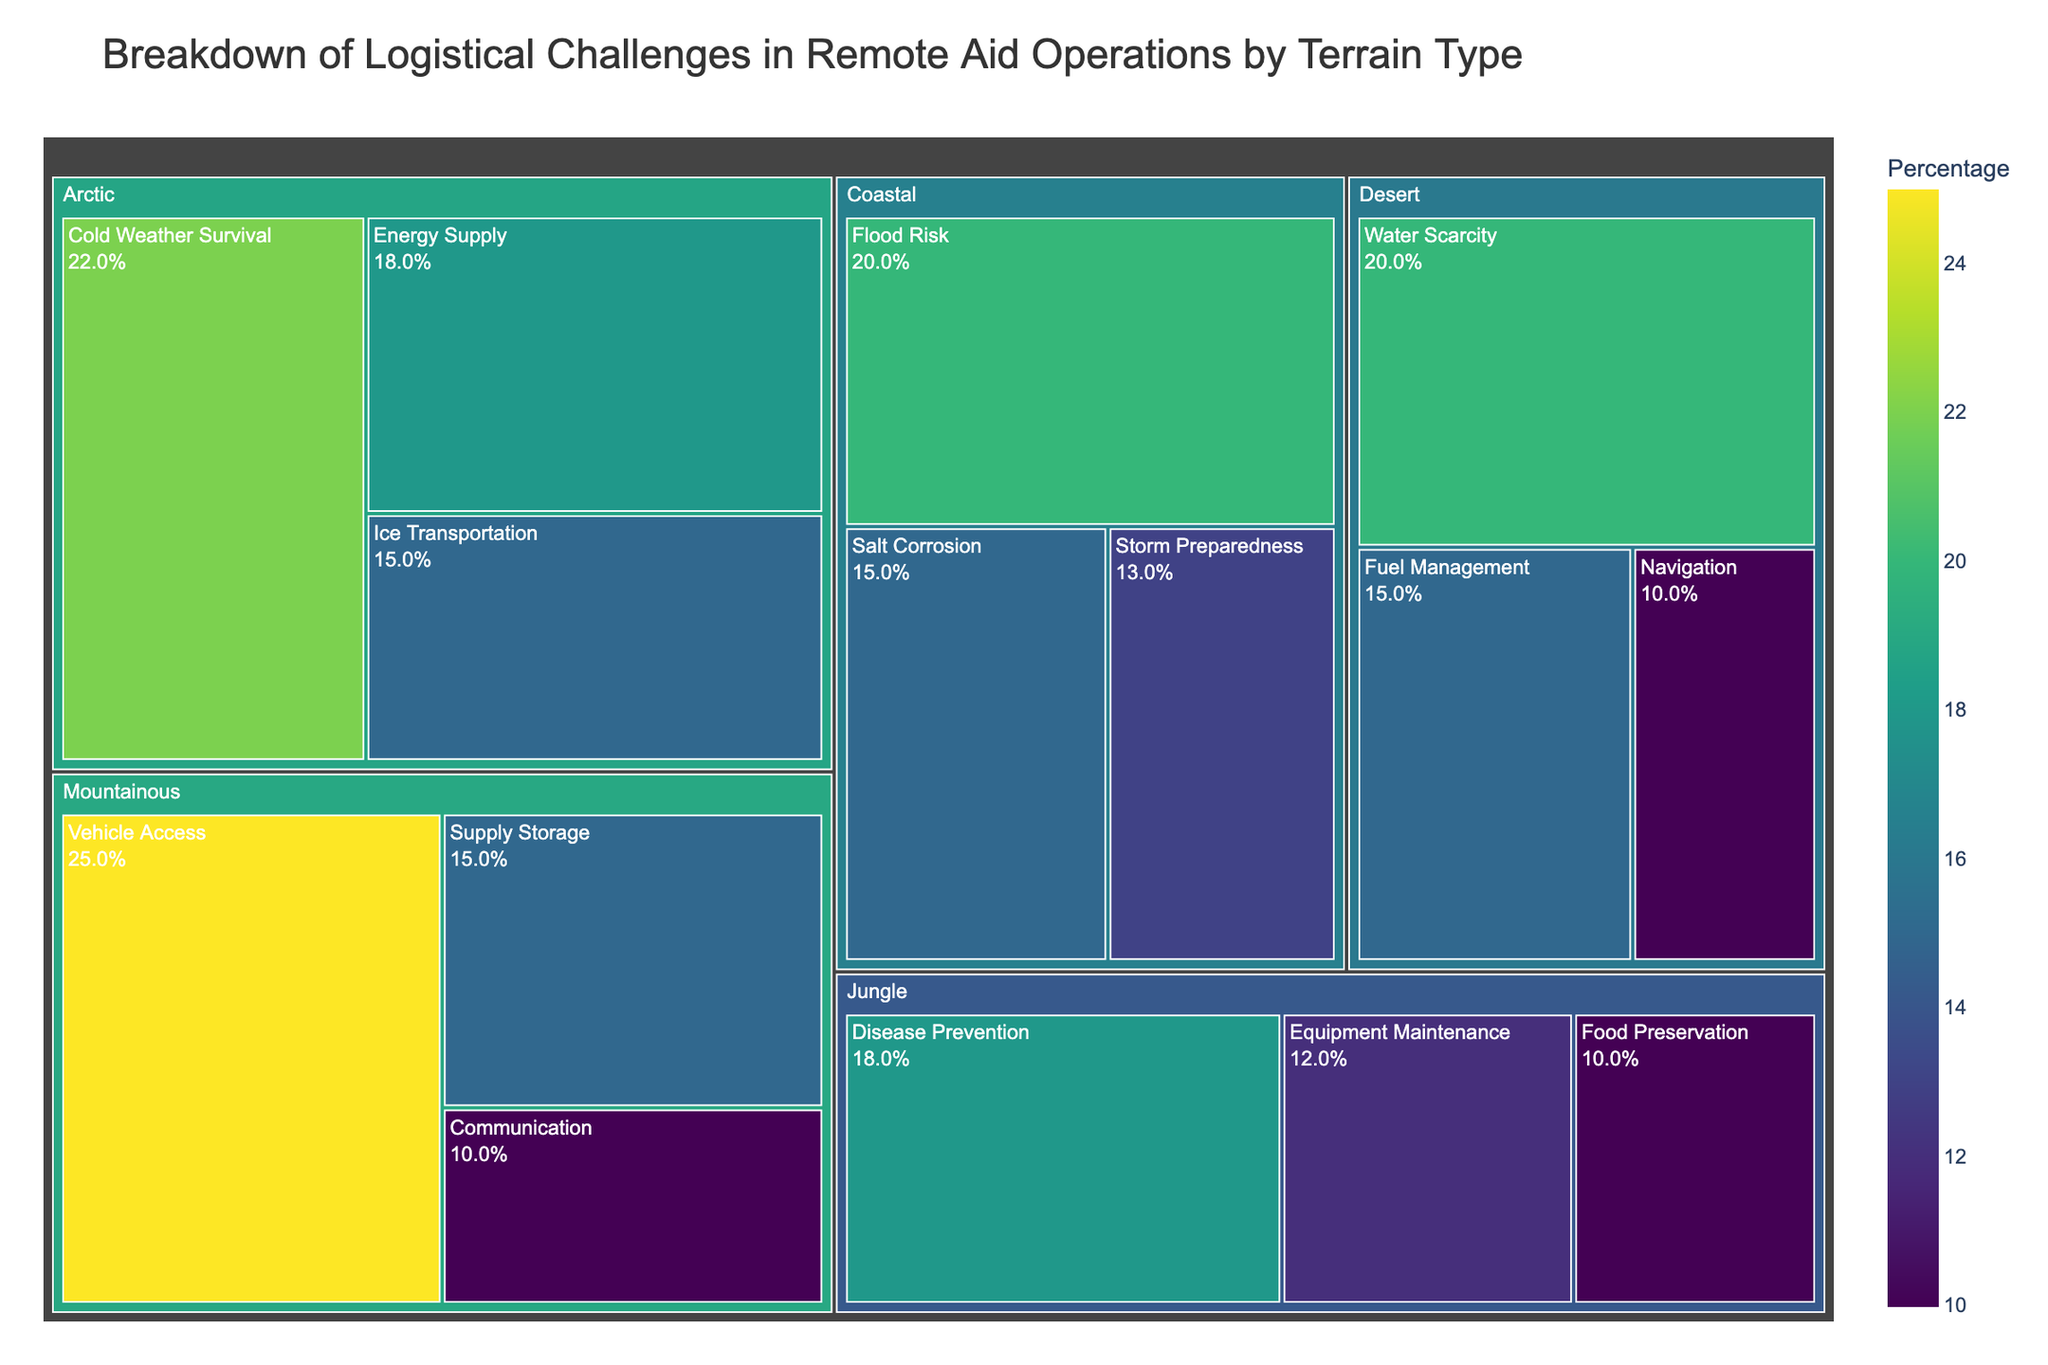What is the title of the treemap? The title of the treemap is located at the top of the figure. It typically describes what the chart is about.
Answer: Breakdown of Logistical Challenges in Remote Aid Operations by Terrain Type Which terrain has the highest percentage of logistical challenges in this treemap? To determine this, look at the parent nodes (Terrains) and find the one that has the largest combined percentage of challenges.
Answer: Mountainous What is the percentage of 'Cold Weather Survival' in the Arctic terrain? Find the 'Arctic' parent node, and then locate the 'Cold Weather Survival' child node to see its percentage value.
Answer: 22% Which challenge has the smallest percentage under the Jungle terrain? Look at the child nodes under the 'Jungle' terrain and identify the one with the smallest percentage.
Answer: Food Preservation Compare the total percentage of challenges in Desert and Jungle terrains. Which one is greater? Sum up the percentages of all challenges for each terrain. Desert: 20 + 15 + 10 = 45, Jungle: 18 + 12 + 10 = 40. Compare the totals.
Answer: Desert What percentage of logistical challenges in the Coastal terrain is related to 'Salt Corrosion'? Locate the 'Coastal' parent node, and then find the 'Salt Corrosion' child node to see its percentage value.
Answer: 15% How does the percentage of 'Energy Supply' in the Arctic compare to 'Equipment Maintenance' in Jungle? Compare the percentage values of 'Energy Supply' in Arctic (18%) and 'Equipment Maintenance' in Jungle (12%).
Answer: Greater What is the combined percentage for 'Vehicle Access' and 'Supply Storage' under Mountainous terrain? Find the percentages for 'Vehicle Access' (25%) and 'Supply Storage' (15%) under Mountainous and sum them up.
Answer: 40% Which terrain has challenges related to 'Flood Risk' and what is its percentage? Locate the terrain that lists 'Flood Risk' as a challenge and check its percentage.
Answer: Coastal, 20% Is 'Navigation' a challenge in Desert or Jungle terrain, and what is its percentage? Search for the 'Navigation' challenge and determine which terrain it belongs to, along with its percentage.
Answer: Desert, 10% 